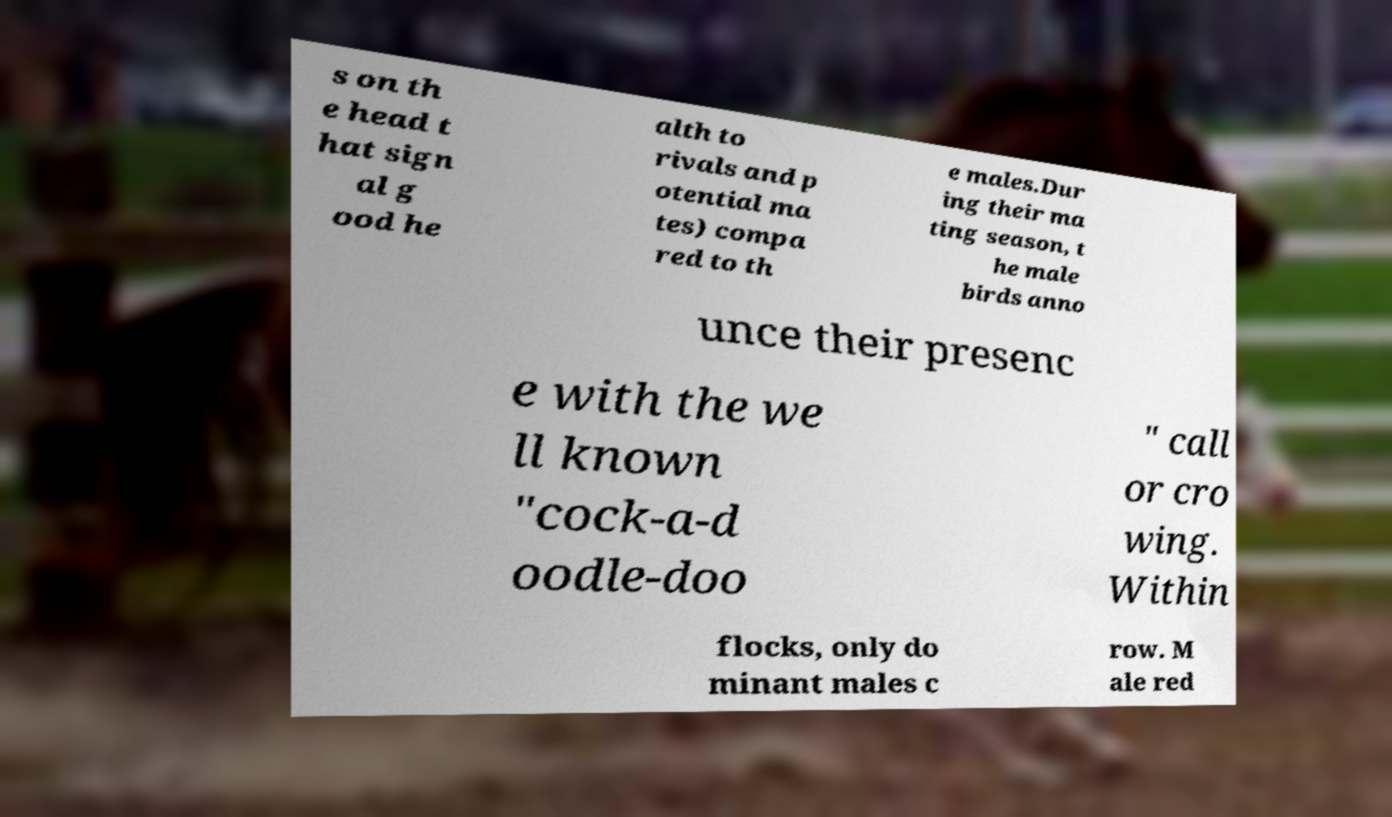Please read and relay the text visible in this image. What does it say? s on th e head t hat sign al g ood he alth to rivals and p otential ma tes) compa red to th e males.Dur ing their ma ting season, t he male birds anno unce their presenc e with the we ll known "cock-a-d oodle-doo " call or cro wing. Within flocks, only do minant males c row. M ale red 